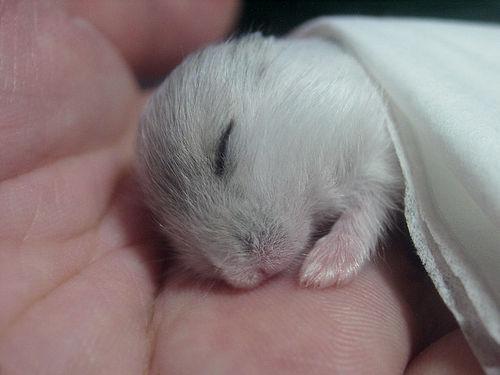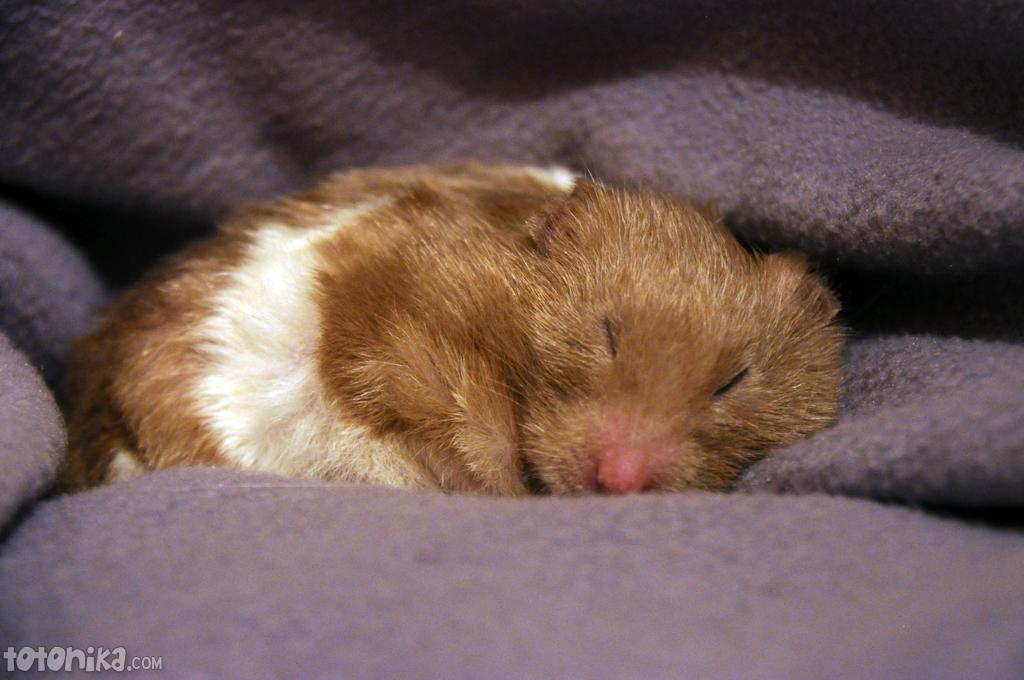The first image is the image on the left, the second image is the image on the right. Assess this claim about the two images: "The hamster in the right image is sleeping.". Correct or not? Answer yes or no. Yes. 